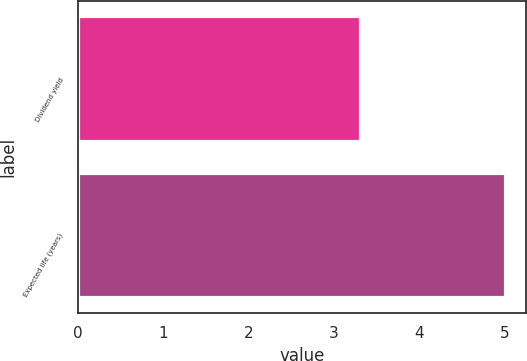Convert chart to OTSL. <chart><loc_0><loc_0><loc_500><loc_500><bar_chart><fcel>Dividend yield<fcel>Expected life (years)<nl><fcel>3.3<fcel>5<nl></chart> 